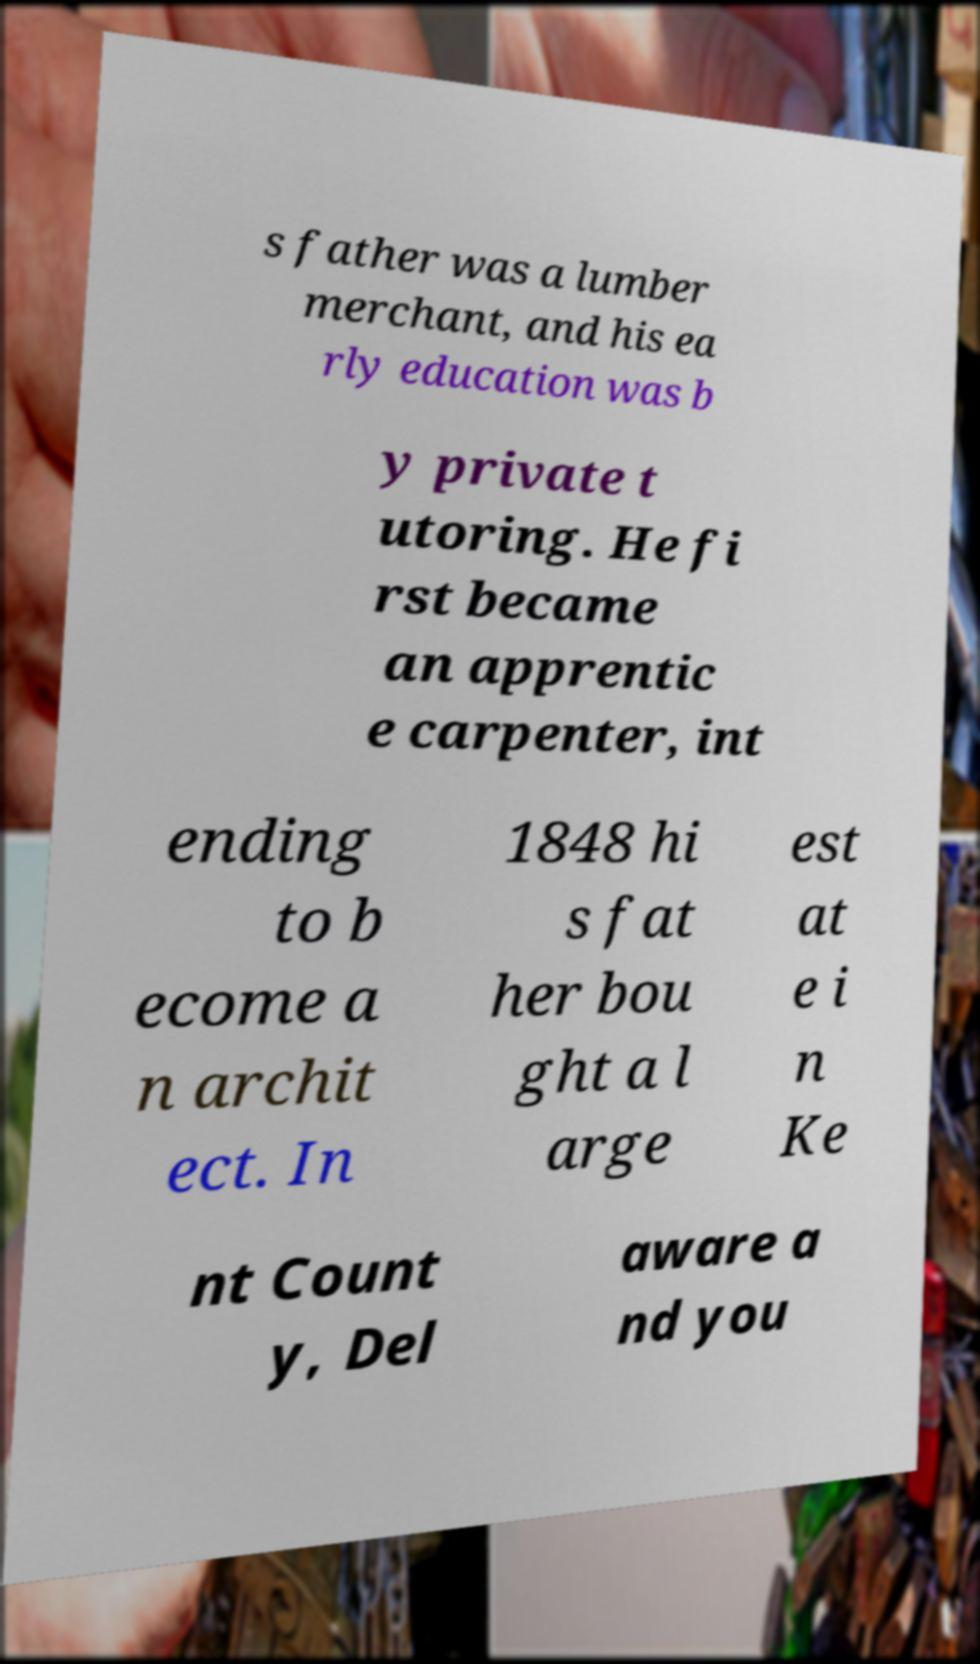For documentation purposes, I need the text within this image transcribed. Could you provide that? s father was a lumber merchant, and his ea rly education was b y private t utoring. He fi rst became an apprentic e carpenter, int ending to b ecome a n archit ect. In 1848 hi s fat her bou ght a l arge est at e i n Ke nt Count y, Del aware a nd you 